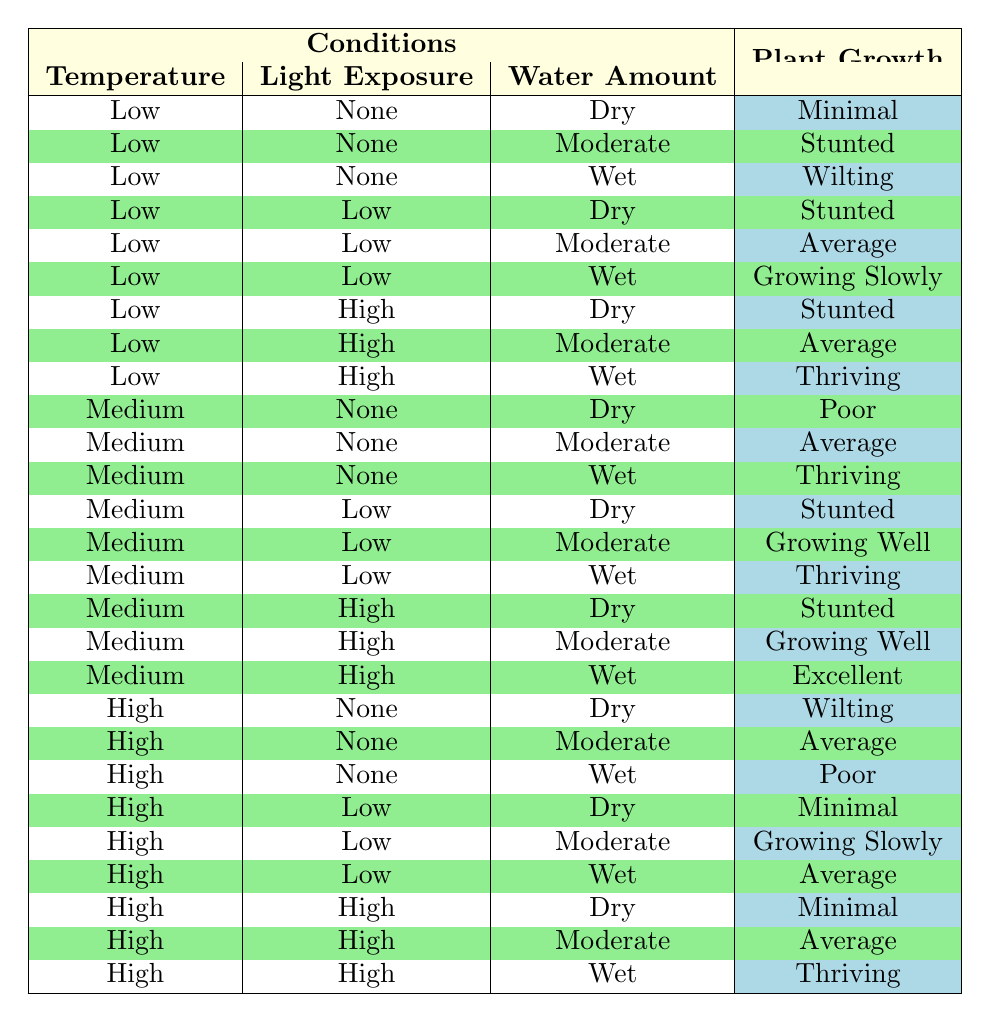What is the plant growth when the temperature is low, light exposure is high, and water amount is wet? By looking at the table, we check the row where the temperature is Low, light exposure is High, and water amount is Wet. The corresponding plant growth listed in that row is Thriving.
Answer: Thriving How many different plant growth outcomes are there for low temperature and moderate water amount? We look for the rows where the temperature is Low and the water amount is Moderate. There are three rows that match this criteria: "Stunted", "Average", and "Growing Slowly". Counting these outcomes gives us a total of three different plant growth outcomes.
Answer: 3 Is it true that all conditions with high temperature and high light exposure result in minimal plant growth? We examine the table for high temperature and high light exposure. There are three conditions under this category: "Minimal", "Average", and "Thriving". Since one of the outcomes is not minimal (it's Average and Thriving), the statement is false.
Answer: No What happens to plant growth when the temperature is medium, light exposure is none, and water amount is dry? We find the row where the temperature is Medium, light exposure is None, and water amount is Dry. The plant growth in that row is Poor.
Answer: Poor Which water amount condition results in the best plant growth at medium temperature with high light exposure? Checking the rows with medium temperature and high light exposure, we analyze the water conditions: Dry (Stunted), Moderate (Growing Well), and Wet (Excellent). The best outcome among these is Wet, which leads to Excellent growth.
Answer: Excellent If we average the plant growth ratings where water amount is wet and temperature is high, what is the outcome? First, we identify the rows where the temperature is High and water amount is Wet. The plant growth outcomes listed are "Poor", "Average", and "Thriving". Assigning a numerical score (e.g., Poor = 1, Average = 2, Thriving = 3), we sum these scores: 1 + 2 + 3 = 6. Next, we divide by the number of outcomes (3), resulting in an average score of 2. Therefore, the average plant growth rating is Average.
Answer: Average How does the plant growth change as light exposure increases from none to high at low temperature with a dry water condition? We examine the rows with Low temperature, Dry water condition, and varying light exposure: "None" (Minimal), "Low" (Stunted), and "High" (Stunted). As light exposure increases from None to High, the plant growth first is Minimal, then remains Stunted. The outcomes show no improvement.
Answer: No improvement Is there a case where high temperature, low light exposure, and moderate water amount result in excellent plant growth? Looking at the table for the specified conditions, there is no row matching high temperature, low light exposure, and moderate water amount leading to Excellent growth. The best outcome in this case is Growing Slowly. Therefore, the claim is false.
Answer: No 